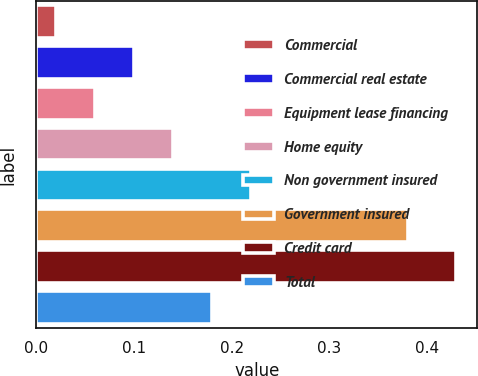Convert chart. <chart><loc_0><loc_0><loc_500><loc_500><bar_chart><fcel>Commercial<fcel>Commercial real estate<fcel>Equipment lease financing<fcel>Home equity<fcel>Non government insured<fcel>Government insured<fcel>Credit card<fcel>Total<nl><fcel>0.02<fcel>0.1<fcel>0.06<fcel>0.14<fcel>0.22<fcel>0.38<fcel>0.43<fcel>0.18<nl></chart> 